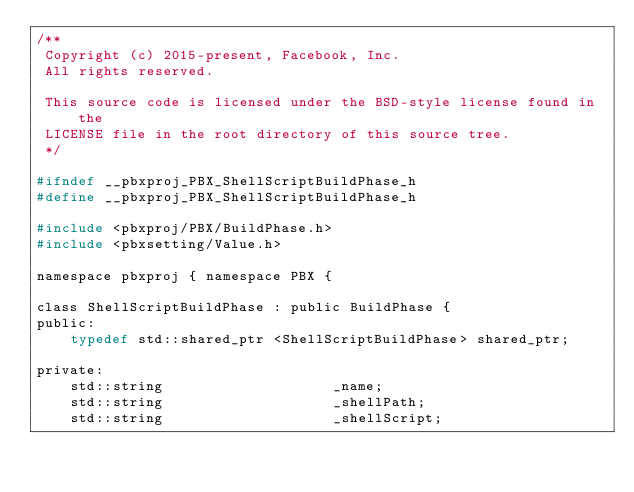<code> <loc_0><loc_0><loc_500><loc_500><_C_>/**
 Copyright (c) 2015-present, Facebook, Inc.
 All rights reserved.

 This source code is licensed under the BSD-style license found in the
 LICENSE file in the root directory of this source tree.
 */

#ifndef __pbxproj_PBX_ShellScriptBuildPhase_h
#define __pbxproj_PBX_ShellScriptBuildPhase_h

#include <pbxproj/PBX/BuildPhase.h>
#include <pbxsetting/Value.h>

namespace pbxproj { namespace PBX {

class ShellScriptBuildPhase : public BuildPhase {
public:
    typedef std::shared_ptr <ShellScriptBuildPhase> shared_ptr;

private:
    std::string                    _name;
    std::string                    _shellPath;
    std::string                    _shellScript;</code> 